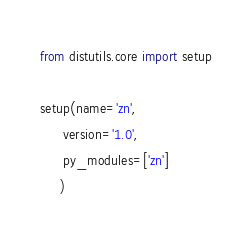Convert code to text. <code><loc_0><loc_0><loc_500><loc_500><_Python_>from distutils.core import setup

setup(name='zn',
      version='1.0',
      py_modules=['zn']
     )</code> 